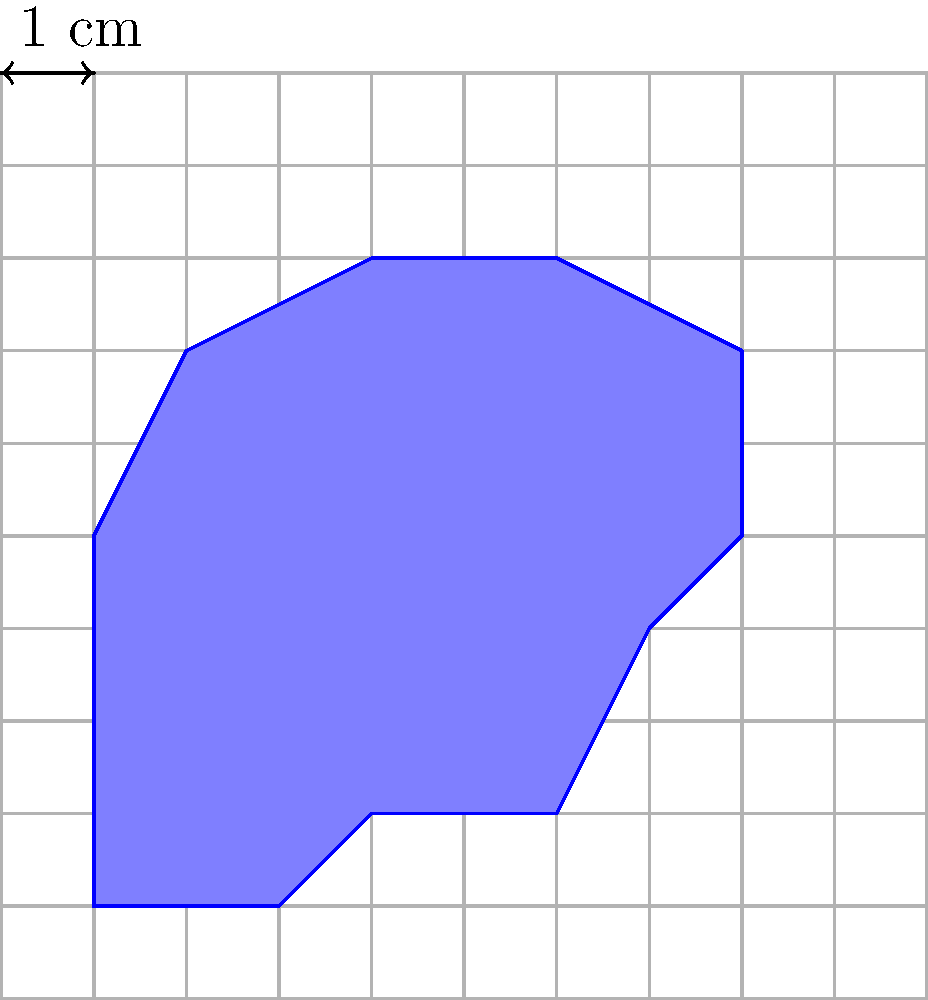As a professional classical piano player, you've received a uniquely shaped piece of sheet music. To determine the appropriate framing size, you need to calculate its area. The sheet is placed on a grid where each square represents 1 cm². Estimate the area of the irregular music sheet to the nearest whole number. To estimate the area of the irregular music sheet, we'll use the counting squares method:

1. Count full squares: There are approximately 25 full squares within the shape.

2. Estimate partial squares:
   - Top edge: About 2.5 partial squares
   - Right edge: About 2 partial squares
   - Bottom edge: About 2 partial squares
   - Left edge: About 1.5 partial squares

3. Sum of partial squares: 2.5 + 2 + 2 + 1.5 = 8

4. Total estimated squares: 25 (full) + 8 (partial) = 33

5. Since each square represents 1 cm², the estimated area is 33 cm².

6. Rounding to the nearest whole number: 33 cm²

This method provides a reasonable estimate for the irregular shape's area.
Answer: 33 cm² 